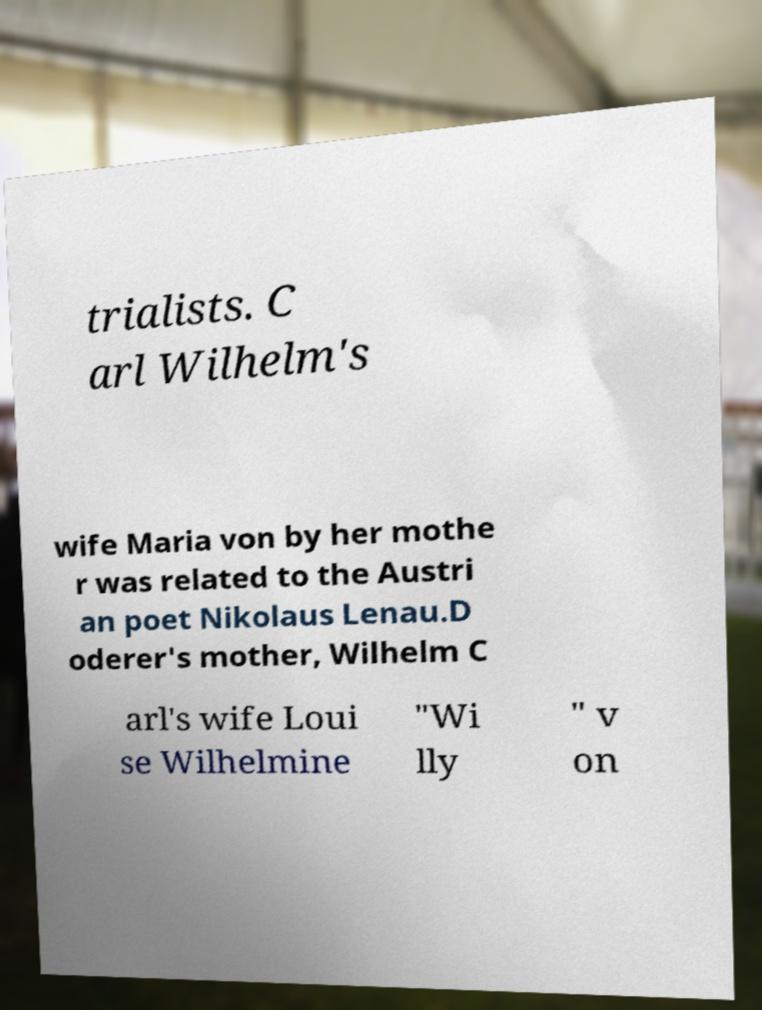Please read and relay the text visible in this image. What does it say? trialists. C arl Wilhelm's wife Maria von by her mothe r was related to the Austri an poet Nikolaus Lenau.D oderer's mother, Wilhelm C arl's wife Loui se Wilhelmine "Wi lly " v on 